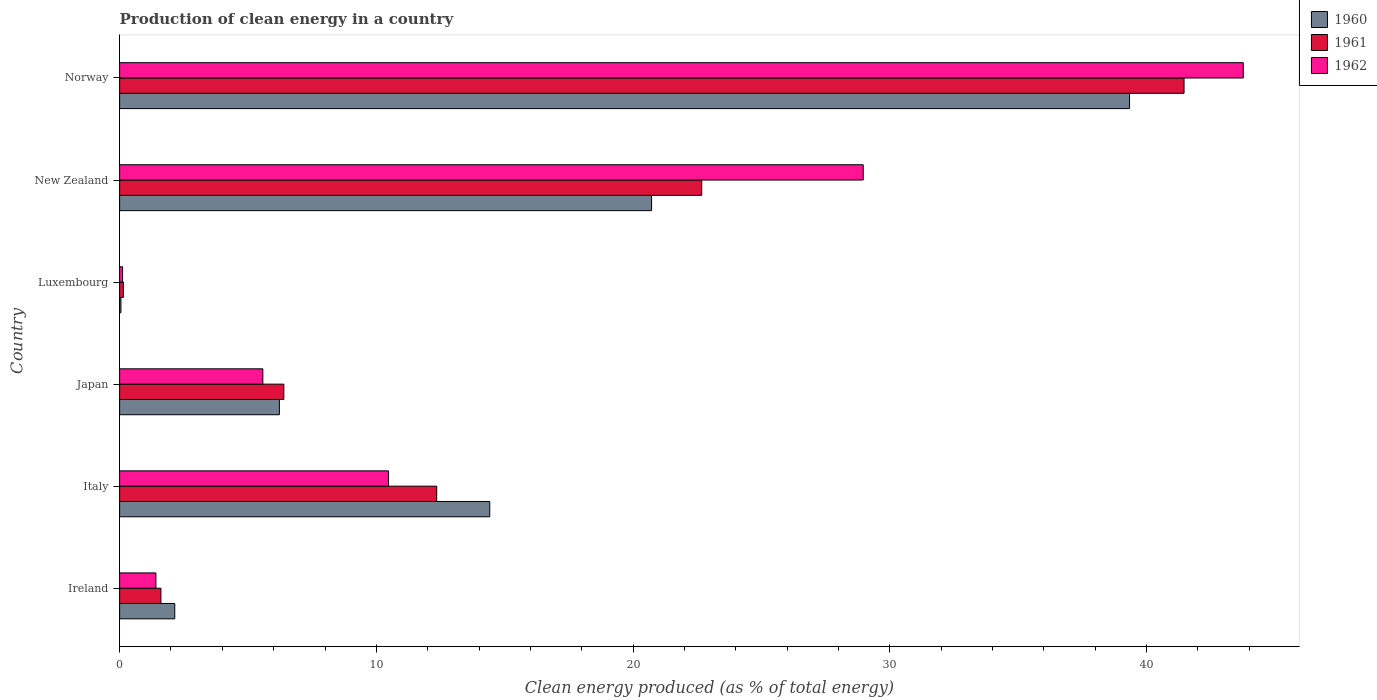How many different coloured bars are there?
Your answer should be very brief. 3. How many groups of bars are there?
Provide a short and direct response. 6. Are the number of bars per tick equal to the number of legend labels?
Make the answer very short. Yes. What is the label of the 1st group of bars from the top?
Ensure brevity in your answer.  Norway. In how many cases, is the number of bars for a given country not equal to the number of legend labels?
Give a very brief answer. 0. What is the percentage of clean energy produced in 1960 in Italy?
Provide a short and direct response. 14.42. Across all countries, what is the maximum percentage of clean energy produced in 1961?
Give a very brief answer. 41.46. Across all countries, what is the minimum percentage of clean energy produced in 1961?
Provide a short and direct response. 0.15. In which country was the percentage of clean energy produced in 1962 maximum?
Provide a short and direct response. Norway. In which country was the percentage of clean energy produced in 1962 minimum?
Offer a terse response. Luxembourg. What is the total percentage of clean energy produced in 1961 in the graph?
Keep it short and to the point. 84.64. What is the difference between the percentage of clean energy produced in 1961 in Italy and that in Luxembourg?
Offer a very short reply. 12.2. What is the difference between the percentage of clean energy produced in 1961 in Luxembourg and the percentage of clean energy produced in 1962 in Japan?
Give a very brief answer. -5.43. What is the average percentage of clean energy produced in 1960 per country?
Provide a short and direct response. 13.82. What is the difference between the percentage of clean energy produced in 1961 and percentage of clean energy produced in 1962 in New Zealand?
Offer a terse response. -6.29. What is the ratio of the percentage of clean energy produced in 1960 in Japan to that in Norway?
Your answer should be compact. 0.16. Is the difference between the percentage of clean energy produced in 1961 in Luxembourg and Norway greater than the difference between the percentage of clean energy produced in 1962 in Luxembourg and Norway?
Provide a succinct answer. Yes. What is the difference between the highest and the second highest percentage of clean energy produced in 1962?
Your answer should be compact. 14.8. What is the difference between the highest and the lowest percentage of clean energy produced in 1961?
Ensure brevity in your answer.  41.31. What does the 2nd bar from the top in Italy represents?
Your answer should be very brief. 1961. How many bars are there?
Make the answer very short. 18. How many countries are there in the graph?
Provide a succinct answer. 6. Does the graph contain any zero values?
Provide a short and direct response. No. Where does the legend appear in the graph?
Provide a succinct answer. Top right. How many legend labels are there?
Your answer should be very brief. 3. How are the legend labels stacked?
Make the answer very short. Vertical. What is the title of the graph?
Keep it short and to the point. Production of clean energy in a country. Does "1965" appear as one of the legend labels in the graph?
Keep it short and to the point. No. What is the label or title of the X-axis?
Your answer should be very brief. Clean energy produced (as % of total energy). What is the label or title of the Y-axis?
Ensure brevity in your answer.  Country. What is the Clean energy produced (as % of total energy) of 1960 in Ireland?
Ensure brevity in your answer.  2.15. What is the Clean energy produced (as % of total energy) in 1961 in Ireland?
Your answer should be compact. 1.61. What is the Clean energy produced (as % of total energy) in 1962 in Ireland?
Provide a short and direct response. 1.41. What is the Clean energy produced (as % of total energy) in 1960 in Italy?
Ensure brevity in your answer.  14.42. What is the Clean energy produced (as % of total energy) in 1961 in Italy?
Provide a succinct answer. 12.35. What is the Clean energy produced (as % of total energy) in 1962 in Italy?
Provide a short and direct response. 10.48. What is the Clean energy produced (as % of total energy) of 1960 in Japan?
Provide a short and direct response. 6.22. What is the Clean energy produced (as % of total energy) in 1961 in Japan?
Provide a succinct answer. 6.4. What is the Clean energy produced (as % of total energy) in 1962 in Japan?
Provide a short and direct response. 5.58. What is the Clean energy produced (as % of total energy) in 1960 in Luxembourg?
Ensure brevity in your answer.  0.05. What is the Clean energy produced (as % of total energy) in 1961 in Luxembourg?
Offer a very short reply. 0.15. What is the Clean energy produced (as % of total energy) of 1962 in Luxembourg?
Offer a terse response. 0.12. What is the Clean energy produced (as % of total energy) in 1960 in New Zealand?
Provide a short and direct response. 20.72. What is the Clean energy produced (as % of total energy) in 1961 in New Zealand?
Make the answer very short. 22.67. What is the Clean energy produced (as % of total energy) of 1962 in New Zealand?
Ensure brevity in your answer.  28.96. What is the Clean energy produced (as % of total energy) in 1960 in Norway?
Your response must be concise. 39.34. What is the Clean energy produced (as % of total energy) in 1961 in Norway?
Provide a short and direct response. 41.46. What is the Clean energy produced (as % of total energy) in 1962 in Norway?
Offer a very short reply. 43.77. Across all countries, what is the maximum Clean energy produced (as % of total energy) of 1960?
Your answer should be very brief. 39.34. Across all countries, what is the maximum Clean energy produced (as % of total energy) of 1961?
Your answer should be compact. 41.46. Across all countries, what is the maximum Clean energy produced (as % of total energy) in 1962?
Make the answer very short. 43.77. Across all countries, what is the minimum Clean energy produced (as % of total energy) in 1960?
Provide a short and direct response. 0.05. Across all countries, what is the minimum Clean energy produced (as % of total energy) in 1961?
Make the answer very short. 0.15. Across all countries, what is the minimum Clean energy produced (as % of total energy) in 1962?
Your answer should be compact. 0.12. What is the total Clean energy produced (as % of total energy) of 1960 in the graph?
Keep it short and to the point. 82.9. What is the total Clean energy produced (as % of total energy) in 1961 in the graph?
Your response must be concise. 84.64. What is the total Clean energy produced (as % of total energy) in 1962 in the graph?
Give a very brief answer. 90.31. What is the difference between the Clean energy produced (as % of total energy) in 1960 in Ireland and that in Italy?
Ensure brevity in your answer.  -12.27. What is the difference between the Clean energy produced (as % of total energy) of 1961 in Ireland and that in Italy?
Provide a short and direct response. -10.74. What is the difference between the Clean energy produced (as % of total energy) in 1962 in Ireland and that in Italy?
Provide a short and direct response. -9.06. What is the difference between the Clean energy produced (as % of total energy) in 1960 in Ireland and that in Japan?
Your response must be concise. -4.08. What is the difference between the Clean energy produced (as % of total energy) of 1961 in Ireland and that in Japan?
Your answer should be very brief. -4.79. What is the difference between the Clean energy produced (as % of total energy) in 1962 in Ireland and that in Japan?
Provide a succinct answer. -4.16. What is the difference between the Clean energy produced (as % of total energy) in 1960 in Ireland and that in Luxembourg?
Give a very brief answer. 2.1. What is the difference between the Clean energy produced (as % of total energy) in 1961 in Ireland and that in Luxembourg?
Ensure brevity in your answer.  1.46. What is the difference between the Clean energy produced (as % of total energy) in 1962 in Ireland and that in Luxembourg?
Your response must be concise. 1.3. What is the difference between the Clean energy produced (as % of total energy) in 1960 in Ireland and that in New Zealand?
Provide a short and direct response. -18.57. What is the difference between the Clean energy produced (as % of total energy) of 1961 in Ireland and that in New Zealand?
Your answer should be compact. -21.06. What is the difference between the Clean energy produced (as % of total energy) in 1962 in Ireland and that in New Zealand?
Provide a short and direct response. -27.55. What is the difference between the Clean energy produced (as % of total energy) of 1960 in Ireland and that in Norway?
Provide a succinct answer. -37.19. What is the difference between the Clean energy produced (as % of total energy) of 1961 in Ireland and that in Norway?
Your response must be concise. -39.85. What is the difference between the Clean energy produced (as % of total energy) in 1962 in Ireland and that in Norway?
Your answer should be compact. -42.35. What is the difference between the Clean energy produced (as % of total energy) in 1960 in Italy and that in Japan?
Your answer should be compact. 8.19. What is the difference between the Clean energy produced (as % of total energy) of 1961 in Italy and that in Japan?
Ensure brevity in your answer.  5.95. What is the difference between the Clean energy produced (as % of total energy) of 1962 in Italy and that in Japan?
Ensure brevity in your answer.  4.9. What is the difference between the Clean energy produced (as % of total energy) in 1960 in Italy and that in Luxembourg?
Provide a short and direct response. 14.37. What is the difference between the Clean energy produced (as % of total energy) of 1961 in Italy and that in Luxembourg?
Make the answer very short. 12.2. What is the difference between the Clean energy produced (as % of total energy) in 1962 in Italy and that in Luxembourg?
Offer a very short reply. 10.36. What is the difference between the Clean energy produced (as % of total energy) in 1960 in Italy and that in New Zealand?
Offer a terse response. -6.3. What is the difference between the Clean energy produced (as % of total energy) in 1961 in Italy and that in New Zealand?
Keep it short and to the point. -10.32. What is the difference between the Clean energy produced (as % of total energy) in 1962 in Italy and that in New Zealand?
Keep it short and to the point. -18.49. What is the difference between the Clean energy produced (as % of total energy) in 1960 in Italy and that in Norway?
Offer a terse response. -24.92. What is the difference between the Clean energy produced (as % of total energy) of 1961 in Italy and that in Norway?
Provide a short and direct response. -29.11. What is the difference between the Clean energy produced (as % of total energy) of 1962 in Italy and that in Norway?
Ensure brevity in your answer.  -33.29. What is the difference between the Clean energy produced (as % of total energy) in 1960 in Japan and that in Luxembourg?
Your response must be concise. 6.17. What is the difference between the Clean energy produced (as % of total energy) of 1961 in Japan and that in Luxembourg?
Your answer should be compact. 6.25. What is the difference between the Clean energy produced (as % of total energy) in 1962 in Japan and that in Luxembourg?
Your answer should be very brief. 5.46. What is the difference between the Clean energy produced (as % of total energy) in 1960 in Japan and that in New Zealand?
Offer a terse response. -14.5. What is the difference between the Clean energy produced (as % of total energy) in 1961 in Japan and that in New Zealand?
Your response must be concise. -16.28. What is the difference between the Clean energy produced (as % of total energy) of 1962 in Japan and that in New Zealand?
Your answer should be compact. -23.38. What is the difference between the Clean energy produced (as % of total energy) of 1960 in Japan and that in Norway?
Ensure brevity in your answer.  -33.11. What is the difference between the Clean energy produced (as % of total energy) in 1961 in Japan and that in Norway?
Offer a terse response. -35.06. What is the difference between the Clean energy produced (as % of total energy) of 1962 in Japan and that in Norway?
Your response must be concise. -38.19. What is the difference between the Clean energy produced (as % of total energy) in 1960 in Luxembourg and that in New Zealand?
Your answer should be very brief. -20.67. What is the difference between the Clean energy produced (as % of total energy) in 1961 in Luxembourg and that in New Zealand?
Your answer should be very brief. -22.53. What is the difference between the Clean energy produced (as % of total energy) of 1962 in Luxembourg and that in New Zealand?
Ensure brevity in your answer.  -28.85. What is the difference between the Clean energy produced (as % of total energy) of 1960 in Luxembourg and that in Norway?
Provide a short and direct response. -39.28. What is the difference between the Clean energy produced (as % of total energy) of 1961 in Luxembourg and that in Norway?
Give a very brief answer. -41.31. What is the difference between the Clean energy produced (as % of total energy) of 1962 in Luxembourg and that in Norway?
Offer a terse response. -43.65. What is the difference between the Clean energy produced (as % of total energy) of 1960 in New Zealand and that in Norway?
Provide a succinct answer. -18.62. What is the difference between the Clean energy produced (as % of total energy) in 1961 in New Zealand and that in Norway?
Make the answer very short. -18.79. What is the difference between the Clean energy produced (as % of total energy) in 1962 in New Zealand and that in Norway?
Provide a succinct answer. -14.8. What is the difference between the Clean energy produced (as % of total energy) in 1960 in Ireland and the Clean energy produced (as % of total energy) in 1961 in Italy?
Make the answer very short. -10.2. What is the difference between the Clean energy produced (as % of total energy) in 1960 in Ireland and the Clean energy produced (as % of total energy) in 1962 in Italy?
Provide a short and direct response. -8.33. What is the difference between the Clean energy produced (as % of total energy) of 1961 in Ireland and the Clean energy produced (as % of total energy) of 1962 in Italy?
Keep it short and to the point. -8.87. What is the difference between the Clean energy produced (as % of total energy) in 1960 in Ireland and the Clean energy produced (as % of total energy) in 1961 in Japan?
Offer a very short reply. -4.25. What is the difference between the Clean energy produced (as % of total energy) of 1960 in Ireland and the Clean energy produced (as % of total energy) of 1962 in Japan?
Offer a terse response. -3.43. What is the difference between the Clean energy produced (as % of total energy) of 1961 in Ireland and the Clean energy produced (as % of total energy) of 1962 in Japan?
Make the answer very short. -3.97. What is the difference between the Clean energy produced (as % of total energy) in 1960 in Ireland and the Clean energy produced (as % of total energy) in 1961 in Luxembourg?
Provide a succinct answer. 2. What is the difference between the Clean energy produced (as % of total energy) of 1960 in Ireland and the Clean energy produced (as % of total energy) of 1962 in Luxembourg?
Provide a short and direct response. 2.03. What is the difference between the Clean energy produced (as % of total energy) of 1961 in Ireland and the Clean energy produced (as % of total energy) of 1962 in Luxembourg?
Give a very brief answer. 1.49. What is the difference between the Clean energy produced (as % of total energy) of 1960 in Ireland and the Clean energy produced (as % of total energy) of 1961 in New Zealand?
Your answer should be very brief. -20.52. What is the difference between the Clean energy produced (as % of total energy) of 1960 in Ireland and the Clean energy produced (as % of total energy) of 1962 in New Zealand?
Make the answer very short. -26.82. What is the difference between the Clean energy produced (as % of total energy) in 1961 in Ireland and the Clean energy produced (as % of total energy) in 1962 in New Zealand?
Give a very brief answer. -27.35. What is the difference between the Clean energy produced (as % of total energy) of 1960 in Ireland and the Clean energy produced (as % of total energy) of 1961 in Norway?
Give a very brief answer. -39.31. What is the difference between the Clean energy produced (as % of total energy) of 1960 in Ireland and the Clean energy produced (as % of total energy) of 1962 in Norway?
Give a very brief answer. -41.62. What is the difference between the Clean energy produced (as % of total energy) in 1961 in Ireland and the Clean energy produced (as % of total energy) in 1962 in Norway?
Your answer should be compact. -42.16. What is the difference between the Clean energy produced (as % of total energy) in 1960 in Italy and the Clean energy produced (as % of total energy) in 1961 in Japan?
Ensure brevity in your answer.  8.02. What is the difference between the Clean energy produced (as % of total energy) of 1960 in Italy and the Clean energy produced (as % of total energy) of 1962 in Japan?
Keep it short and to the point. 8.84. What is the difference between the Clean energy produced (as % of total energy) of 1961 in Italy and the Clean energy produced (as % of total energy) of 1962 in Japan?
Your answer should be very brief. 6.77. What is the difference between the Clean energy produced (as % of total energy) in 1960 in Italy and the Clean energy produced (as % of total energy) in 1961 in Luxembourg?
Make the answer very short. 14.27. What is the difference between the Clean energy produced (as % of total energy) in 1960 in Italy and the Clean energy produced (as % of total energy) in 1962 in Luxembourg?
Provide a short and direct response. 14.3. What is the difference between the Clean energy produced (as % of total energy) of 1961 in Italy and the Clean energy produced (as % of total energy) of 1962 in Luxembourg?
Provide a short and direct response. 12.23. What is the difference between the Clean energy produced (as % of total energy) of 1960 in Italy and the Clean energy produced (as % of total energy) of 1961 in New Zealand?
Offer a very short reply. -8.26. What is the difference between the Clean energy produced (as % of total energy) of 1960 in Italy and the Clean energy produced (as % of total energy) of 1962 in New Zealand?
Make the answer very short. -14.55. What is the difference between the Clean energy produced (as % of total energy) in 1961 in Italy and the Clean energy produced (as % of total energy) in 1962 in New Zealand?
Keep it short and to the point. -16.61. What is the difference between the Clean energy produced (as % of total energy) in 1960 in Italy and the Clean energy produced (as % of total energy) in 1961 in Norway?
Keep it short and to the point. -27.04. What is the difference between the Clean energy produced (as % of total energy) in 1960 in Italy and the Clean energy produced (as % of total energy) in 1962 in Norway?
Provide a short and direct response. -29.35. What is the difference between the Clean energy produced (as % of total energy) in 1961 in Italy and the Clean energy produced (as % of total energy) in 1962 in Norway?
Ensure brevity in your answer.  -31.41. What is the difference between the Clean energy produced (as % of total energy) in 1960 in Japan and the Clean energy produced (as % of total energy) in 1961 in Luxembourg?
Give a very brief answer. 6.08. What is the difference between the Clean energy produced (as % of total energy) of 1960 in Japan and the Clean energy produced (as % of total energy) of 1962 in Luxembourg?
Make the answer very short. 6.11. What is the difference between the Clean energy produced (as % of total energy) of 1961 in Japan and the Clean energy produced (as % of total energy) of 1962 in Luxembourg?
Your response must be concise. 6.28. What is the difference between the Clean energy produced (as % of total energy) in 1960 in Japan and the Clean energy produced (as % of total energy) in 1961 in New Zealand?
Offer a terse response. -16.45. What is the difference between the Clean energy produced (as % of total energy) of 1960 in Japan and the Clean energy produced (as % of total energy) of 1962 in New Zealand?
Provide a short and direct response. -22.74. What is the difference between the Clean energy produced (as % of total energy) of 1961 in Japan and the Clean energy produced (as % of total energy) of 1962 in New Zealand?
Provide a succinct answer. -22.57. What is the difference between the Clean energy produced (as % of total energy) of 1960 in Japan and the Clean energy produced (as % of total energy) of 1961 in Norway?
Provide a short and direct response. -35.24. What is the difference between the Clean energy produced (as % of total energy) in 1960 in Japan and the Clean energy produced (as % of total energy) in 1962 in Norway?
Ensure brevity in your answer.  -37.54. What is the difference between the Clean energy produced (as % of total energy) in 1961 in Japan and the Clean energy produced (as % of total energy) in 1962 in Norway?
Keep it short and to the point. -37.37. What is the difference between the Clean energy produced (as % of total energy) in 1960 in Luxembourg and the Clean energy produced (as % of total energy) in 1961 in New Zealand?
Your answer should be compact. -22.62. What is the difference between the Clean energy produced (as % of total energy) of 1960 in Luxembourg and the Clean energy produced (as % of total energy) of 1962 in New Zealand?
Make the answer very short. -28.91. What is the difference between the Clean energy produced (as % of total energy) in 1961 in Luxembourg and the Clean energy produced (as % of total energy) in 1962 in New Zealand?
Make the answer very short. -28.82. What is the difference between the Clean energy produced (as % of total energy) in 1960 in Luxembourg and the Clean energy produced (as % of total energy) in 1961 in Norway?
Ensure brevity in your answer.  -41.41. What is the difference between the Clean energy produced (as % of total energy) in 1960 in Luxembourg and the Clean energy produced (as % of total energy) in 1962 in Norway?
Provide a short and direct response. -43.71. What is the difference between the Clean energy produced (as % of total energy) of 1961 in Luxembourg and the Clean energy produced (as % of total energy) of 1962 in Norway?
Your answer should be compact. -43.62. What is the difference between the Clean energy produced (as % of total energy) of 1960 in New Zealand and the Clean energy produced (as % of total energy) of 1961 in Norway?
Make the answer very short. -20.74. What is the difference between the Clean energy produced (as % of total energy) in 1960 in New Zealand and the Clean energy produced (as % of total energy) in 1962 in Norway?
Keep it short and to the point. -23.05. What is the difference between the Clean energy produced (as % of total energy) of 1961 in New Zealand and the Clean energy produced (as % of total energy) of 1962 in Norway?
Ensure brevity in your answer.  -21.09. What is the average Clean energy produced (as % of total energy) of 1960 per country?
Provide a short and direct response. 13.82. What is the average Clean energy produced (as % of total energy) of 1961 per country?
Make the answer very short. 14.11. What is the average Clean energy produced (as % of total energy) in 1962 per country?
Offer a terse response. 15.05. What is the difference between the Clean energy produced (as % of total energy) of 1960 and Clean energy produced (as % of total energy) of 1961 in Ireland?
Offer a terse response. 0.54. What is the difference between the Clean energy produced (as % of total energy) of 1960 and Clean energy produced (as % of total energy) of 1962 in Ireland?
Make the answer very short. 0.73. What is the difference between the Clean energy produced (as % of total energy) of 1961 and Clean energy produced (as % of total energy) of 1962 in Ireland?
Ensure brevity in your answer.  0.19. What is the difference between the Clean energy produced (as % of total energy) in 1960 and Clean energy produced (as % of total energy) in 1961 in Italy?
Your answer should be very brief. 2.07. What is the difference between the Clean energy produced (as % of total energy) in 1960 and Clean energy produced (as % of total energy) in 1962 in Italy?
Your response must be concise. 3.94. What is the difference between the Clean energy produced (as % of total energy) in 1961 and Clean energy produced (as % of total energy) in 1962 in Italy?
Provide a short and direct response. 1.87. What is the difference between the Clean energy produced (as % of total energy) of 1960 and Clean energy produced (as % of total energy) of 1961 in Japan?
Offer a terse response. -0.17. What is the difference between the Clean energy produced (as % of total energy) of 1960 and Clean energy produced (as % of total energy) of 1962 in Japan?
Your answer should be compact. 0.64. What is the difference between the Clean energy produced (as % of total energy) of 1961 and Clean energy produced (as % of total energy) of 1962 in Japan?
Ensure brevity in your answer.  0.82. What is the difference between the Clean energy produced (as % of total energy) of 1960 and Clean energy produced (as % of total energy) of 1961 in Luxembourg?
Provide a short and direct response. -0.09. What is the difference between the Clean energy produced (as % of total energy) of 1960 and Clean energy produced (as % of total energy) of 1962 in Luxembourg?
Keep it short and to the point. -0.06. What is the difference between the Clean energy produced (as % of total energy) of 1961 and Clean energy produced (as % of total energy) of 1962 in Luxembourg?
Provide a succinct answer. 0.03. What is the difference between the Clean energy produced (as % of total energy) of 1960 and Clean energy produced (as % of total energy) of 1961 in New Zealand?
Keep it short and to the point. -1.95. What is the difference between the Clean energy produced (as % of total energy) of 1960 and Clean energy produced (as % of total energy) of 1962 in New Zealand?
Keep it short and to the point. -8.24. What is the difference between the Clean energy produced (as % of total energy) in 1961 and Clean energy produced (as % of total energy) in 1962 in New Zealand?
Your answer should be compact. -6.29. What is the difference between the Clean energy produced (as % of total energy) in 1960 and Clean energy produced (as % of total energy) in 1961 in Norway?
Offer a very short reply. -2.12. What is the difference between the Clean energy produced (as % of total energy) in 1960 and Clean energy produced (as % of total energy) in 1962 in Norway?
Keep it short and to the point. -4.43. What is the difference between the Clean energy produced (as % of total energy) of 1961 and Clean energy produced (as % of total energy) of 1962 in Norway?
Ensure brevity in your answer.  -2.31. What is the ratio of the Clean energy produced (as % of total energy) of 1960 in Ireland to that in Italy?
Your answer should be compact. 0.15. What is the ratio of the Clean energy produced (as % of total energy) in 1961 in Ireland to that in Italy?
Your response must be concise. 0.13. What is the ratio of the Clean energy produced (as % of total energy) in 1962 in Ireland to that in Italy?
Ensure brevity in your answer.  0.14. What is the ratio of the Clean energy produced (as % of total energy) in 1960 in Ireland to that in Japan?
Your answer should be compact. 0.35. What is the ratio of the Clean energy produced (as % of total energy) in 1961 in Ireland to that in Japan?
Your response must be concise. 0.25. What is the ratio of the Clean energy produced (as % of total energy) of 1962 in Ireland to that in Japan?
Ensure brevity in your answer.  0.25. What is the ratio of the Clean energy produced (as % of total energy) of 1960 in Ireland to that in Luxembourg?
Your answer should be very brief. 41.27. What is the ratio of the Clean energy produced (as % of total energy) of 1961 in Ireland to that in Luxembourg?
Provide a short and direct response. 10.96. What is the ratio of the Clean energy produced (as % of total energy) of 1962 in Ireland to that in Luxembourg?
Provide a short and direct response. 12.21. What is the ratio of the Clean energy produced (as % of total energy) of 1960 in Ireland to that in New Zealand?
Make the answer very short. 0.1. What is the ratio of the Clean energy produced (as % of total energy) in 1961 in Ireland to that in New Zealand?
Offer a very short reply. 0.07. What is the ratio of the Clean energy produced (as % of total energy) of 1962 in Ireland to that in New Zealand?
Offer a very short reply. 0.05. What is the ratio of the Clean energy produced (as % of total energy) in 1960 in Ireland to that in Norway?
Offer a very short reply. 0.05. What is the ratio of the Clean energy produced (as % of total energy) of 1961 in Ireland to that in Norway?
Keep it short and to the point. 0.04. What is the ratio of the Clean energy produced (as % of total energy) of 1962 in Ireland to that in Norway?
Offer a very short reply. 0.03. What is the ratio of the Clean energy produced (as % of total energy) of 1960 in Italy to that in Japan?
Give a very brief answer. 2.32. What is the ratio of the Clean energy produced (as % of total energy) of 1961 in Italy to that in Japan?
Give a very brief answer. 1.93. What is the ratio of the Clean energy produced (as % of total energy) in 1962 in Italy to that in Japan?
Give a very brief answer. 1.88. What is the ratio of the Clean energy produced (as % of total energy) in 1960 in Italy to that in Luxembourg?
Your answer should be very brief. 276.95. What is the ratio of the Clean energy produced (as % of total energy) of 1961 in Italy to that in Luxembourg?
Your answer should be compact. 84.09. What is the ratio of the Clean energy produced (as % of total energy) of 1962 in Italy to that in Luxembourg?
Offer a very short reply. 90.43. What is the ratio of the Clean energy produced (as % of total energy) in 1960 in Italy to that in New Zealand?
Keep it short and to the point. 0.7. What is the ratio of the Clean energy produced (as % of total energy) in 1961 in Italy to that in New Zealand?
Provide a succinct answer. 0.54. What is the ratio of the Clean energy produced (as % of total energy) of 1962 in Italy to that in New Zealand?
Give a very brief answer. 0.36. What is the ratio of the Clean energy produced (as % of total energy) in 1960 in Italy to that in Norway?
Give a very brief answer. 0.37. What is the ratio of the Clean energy produced (as % of total energy) in 1961 in Italy to that in Norway?
Offer a terse response. 0.3. What is the ratio of the Clean energy produced (as % of total energy) of 1962 in Italy to that in Norway?
Provide a succinct answer. 0.24. What is the ratio of the Clean energy produced (as % of total energy) in 1960 in Japan to that in Luxembourg?
Offer a terse response. 119.55. What is the ratio of the Clean energy produced (as % of total energy) in 1961 in Japan to that in Luxembourg?
Ensure brevity in your answer.  43.55. What is the ratio of the Clean energy produced (as % of total energy) of 1962 in Japan to that in Luxembourg?
Your response must be concise. 48.16. What is the ratio of the Clean energy produced (as % of total energy) in 1960 in Japan to that in New Zealand?
Your response must be concise. 0.3. What is the ratio of the Clean energy produced (as % of total energy) in 1961 in Japan to that in New Zealand?
Ensure brevity in your answer.  0.28. What is the ratio of the Clean energy produced (as % of total energy) in 1962 in Japan to that in New Zealand?
Keep it short and to the point. 0.19. What is the ratio of the Clean energy produced (as % of total energy) in 1960 in Japan to that in Norway?
Offer a terse response. 0.16. What is the ratio of the Clean energy produced (as % of total energy) of 1961 in Japan to that in Norway?
Offer a very short reply. 0.15. What is the ratio of the Clean energy produced (as % of total energy) in 1962 in Japan to that in Norway?
Provide a succinct answer. 0.13. What is the ratio of the Clean energy produced (as % of total energy) in 1960 in Luxembourg to that in New Zealand?
Provide a succinct answer. 0. What is the ratio of the Clean energy produced (as % of total energy) in 1961 in Luxembourg to that in New Zealand?
Provide a succinct answer. 0.01. What is the ratio of the Clean energy produced (as % of total energy) of 1962 in Luxembourg to that in New Zealand?
Provide a short and direct response. 0. What is the ratio of the Clean energy produced (as % of total energy) of 1960 in Luxembourg to that in Norway?
Keep it short and to the point. 0. What is the ratio of the Clean energy produced (as % of total energy) of 1961 in Luxembourg to that in Norway?
Your answer should be very brief. 0. What is the ratio of the Clean energy produced (as % of total energy) of 1962 in Luxembourg to that in Norway?
Provide a short and direct response. 0. What is the ratio of the Clean energy produced (as % of total energy) of 1960 in New Zealand to that in Norway?
Offer a terse response. 0.53. What is the ratio of the Clean energy produced (as % of total energy) in 1961 in New Zealand to that in Norway?
Ensure brevity in your answer.  0.55. What is the ratio of the Clean energy produced (as % of total energy) in 1962 in New Zealand to that in Norway?
Offer a very short reply. 0.66. What is the difference between the highest and the second highest Clean energy produced (as % of total energy) of 1960?
Offer a very short reply. 18.62. What is the difference between the highest and the second highest Clean energy produced (as % of total energy) in 1961?
Give a very brief answer. 18.79. What is the difference between the highest and the second highest Clean energy produced (as % of total energy) in 1962?
Give a very brief answer. 14.8. What is the difference between the highest and the lowest Clean energy produced (as % of total energy) of 1960?
Your response must be concise. 39.28. What is the difference between the highest and the lowest Clean energy produced (as % of total energy) in 1961?
Provide a short and direct response. 41.31. What is the difference between the highest and the lowest Clean energy produced (as % of total energy) of 1962?
Keep it short and to the point. 43.65. 